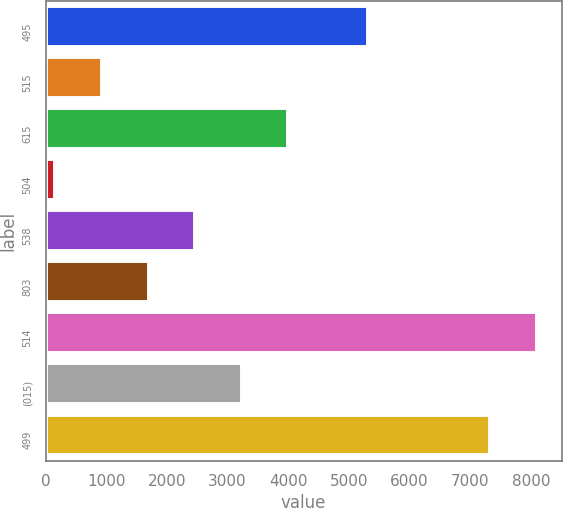Convert chart. <chart><loc_0><loc_0><loc_500><loc_500><bar_chart><fcel>495<fcel>515<fcel>615<fcel>504<fcel>538<fcel>803<fcel>514<fcel>(015)<fcel>499<nl><fcel>5315<fcel>927<fcel>4003<fcel>158<fcel>2465<fcel>1696<fcel>8102<fcel>3234<fcel>7333<nl></chart> 